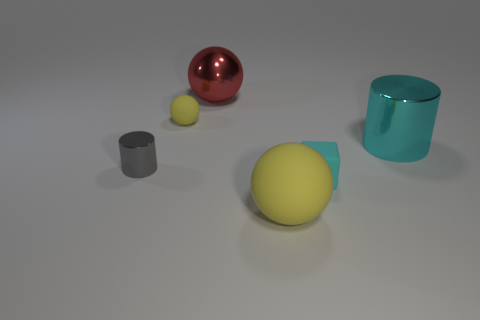Add 4 purple cylinders. How many objects exist? 10 Subtract all cubes. How many objects are left? 5 Subtract 0 purple spheres. How many objects are left? 6 Subtract all big green rubber spheres. Subtract all gray things. How many objects are left? 5 Add 6 tiny gray metallic things. How many tiny gray metallic things are left? 7 Add 5 large purple rubber objects. How many large purple rubber objects exist? 5 